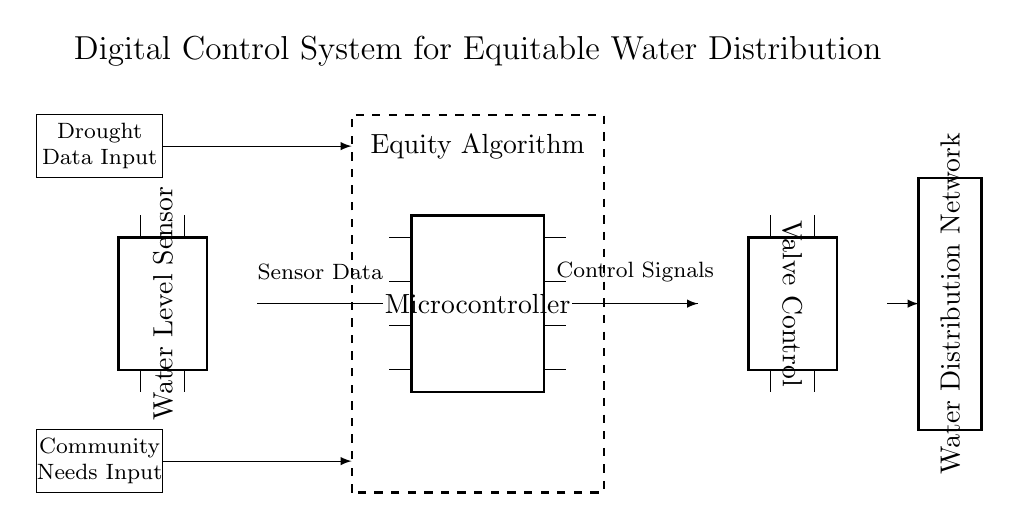What is the function of the water level sensor? The water level sensor detects the water level and sends data to the microcontroller for processing.
Answer: Detect water level What does the equity algorithm do? The equity algorithm processes inputs to ensure fair distribution of water according to community needs and drought data.
Answer: Ensure fair distribution How many pins does the microcontroller have? The microcontroller has eight pins as indicated by the diagram representation.
Answer: Eight pins What are the main inputs to the system? The main inputs are drought data and community needs, shown as separate blocks feeding into the system.
Answer: Drought data and community needs What type of system is depicted in the diagram? The system is a digital control system designed for equitable water distribution in drought-affected areas.
Answer: Digital control system What does the water distribution network represent? The water distribution network represents the physical system that delivers water to the community based on processed control signals.
Answer: Deliver water to community How is data communicated from the water level sensor to the valve control? Data from the water level sensor is transmitted as control signals through the microcontroller to the valve control component.
Answer: Through the microcontroller 